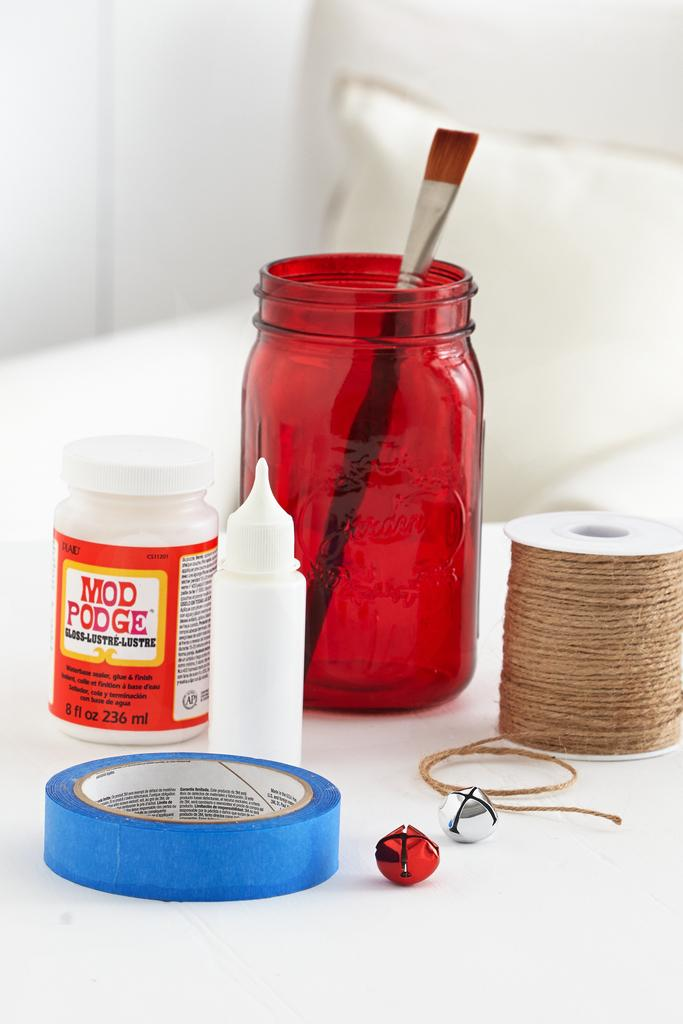<image>
Give a short and clear explanation of the subsequent image. Bottle of red and white Mod Podge next to a red container with a paintbrush. 